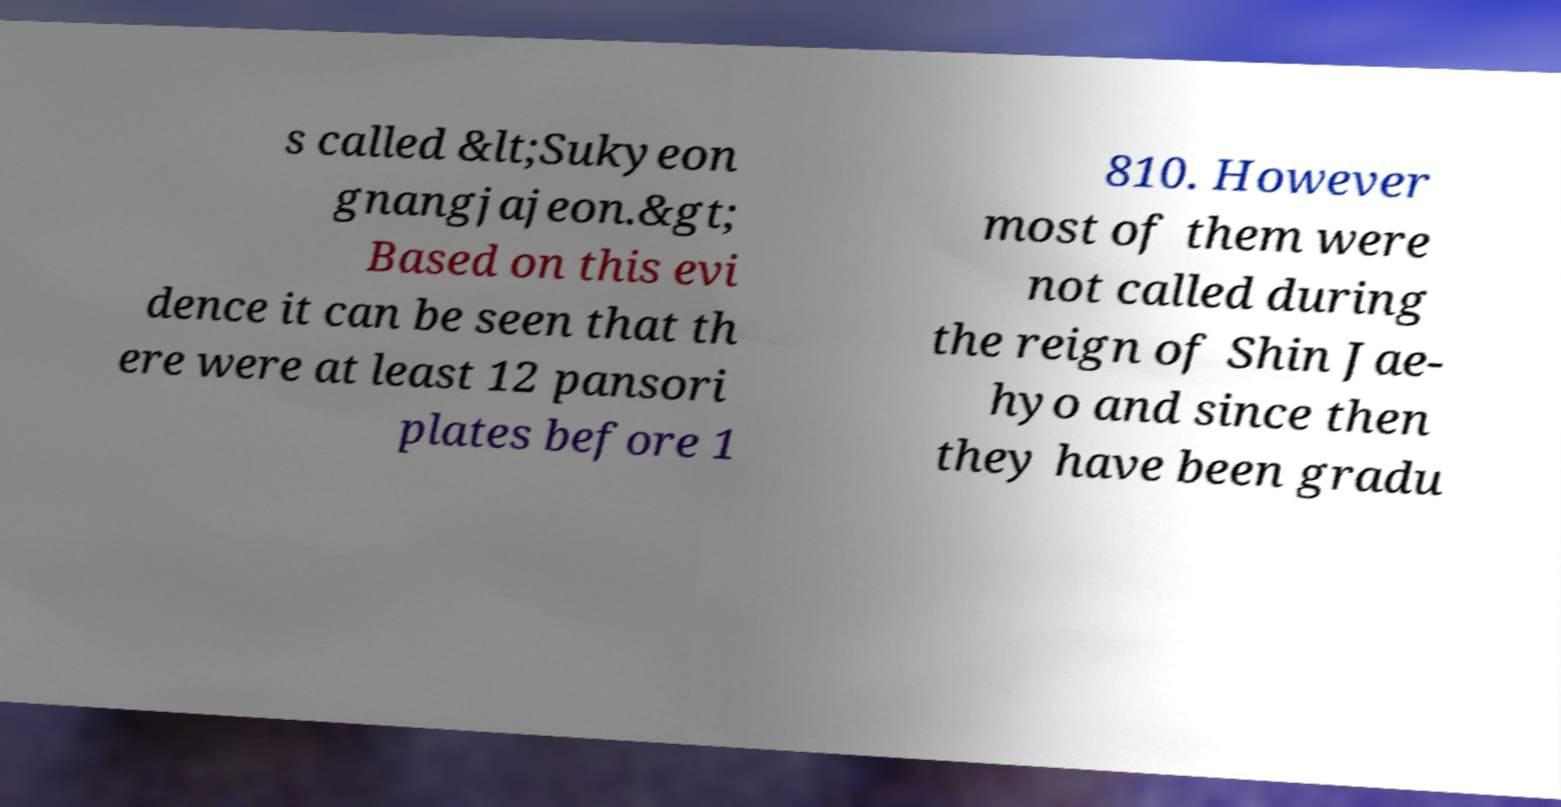Could you assist in decoding the text presented in this image and type it out clearly? s called &lt;Sukyeon gnangjajeon.&gt; Based on this evi dence it can be seen that th ere were at least 12 pansori plates before 1 810. However most of them were not called during the reign of Shin Jae- hyo and since then they have been gradu 